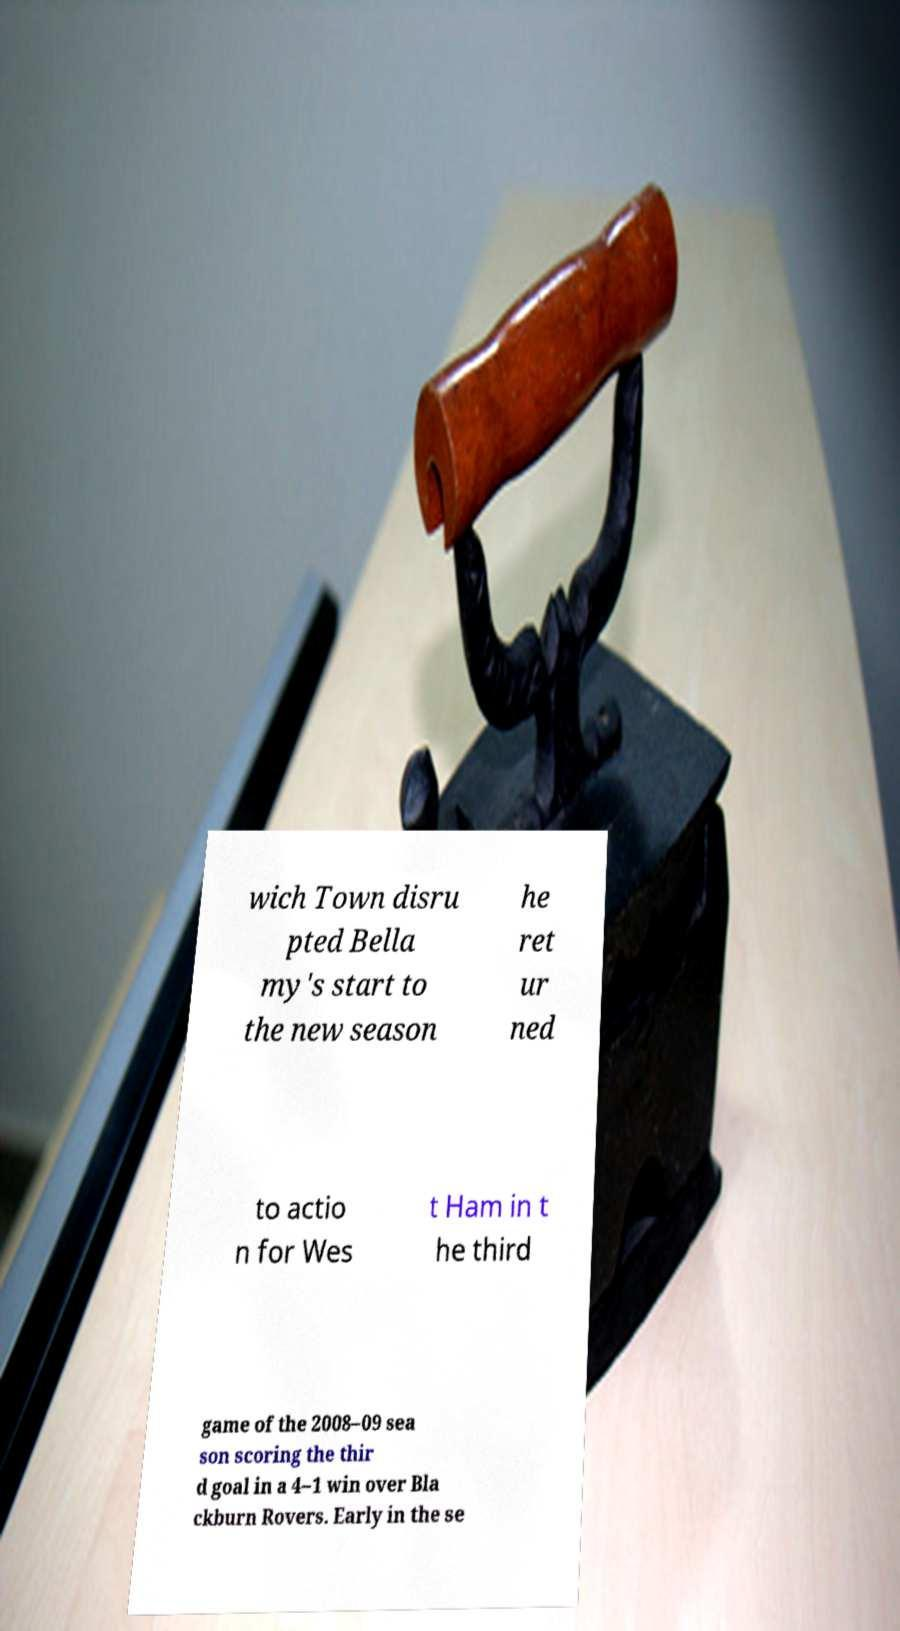I need the written content from this picture converted into text. Can you do that? wich Town disru pted Bella my's start to the new season he ret ur ned to actio n for Wes t Ham in t he third game of the 2008–09 sea son scoring the thir d goal in a 4–1 win over Bla ckburn Rovers. Early in the se 